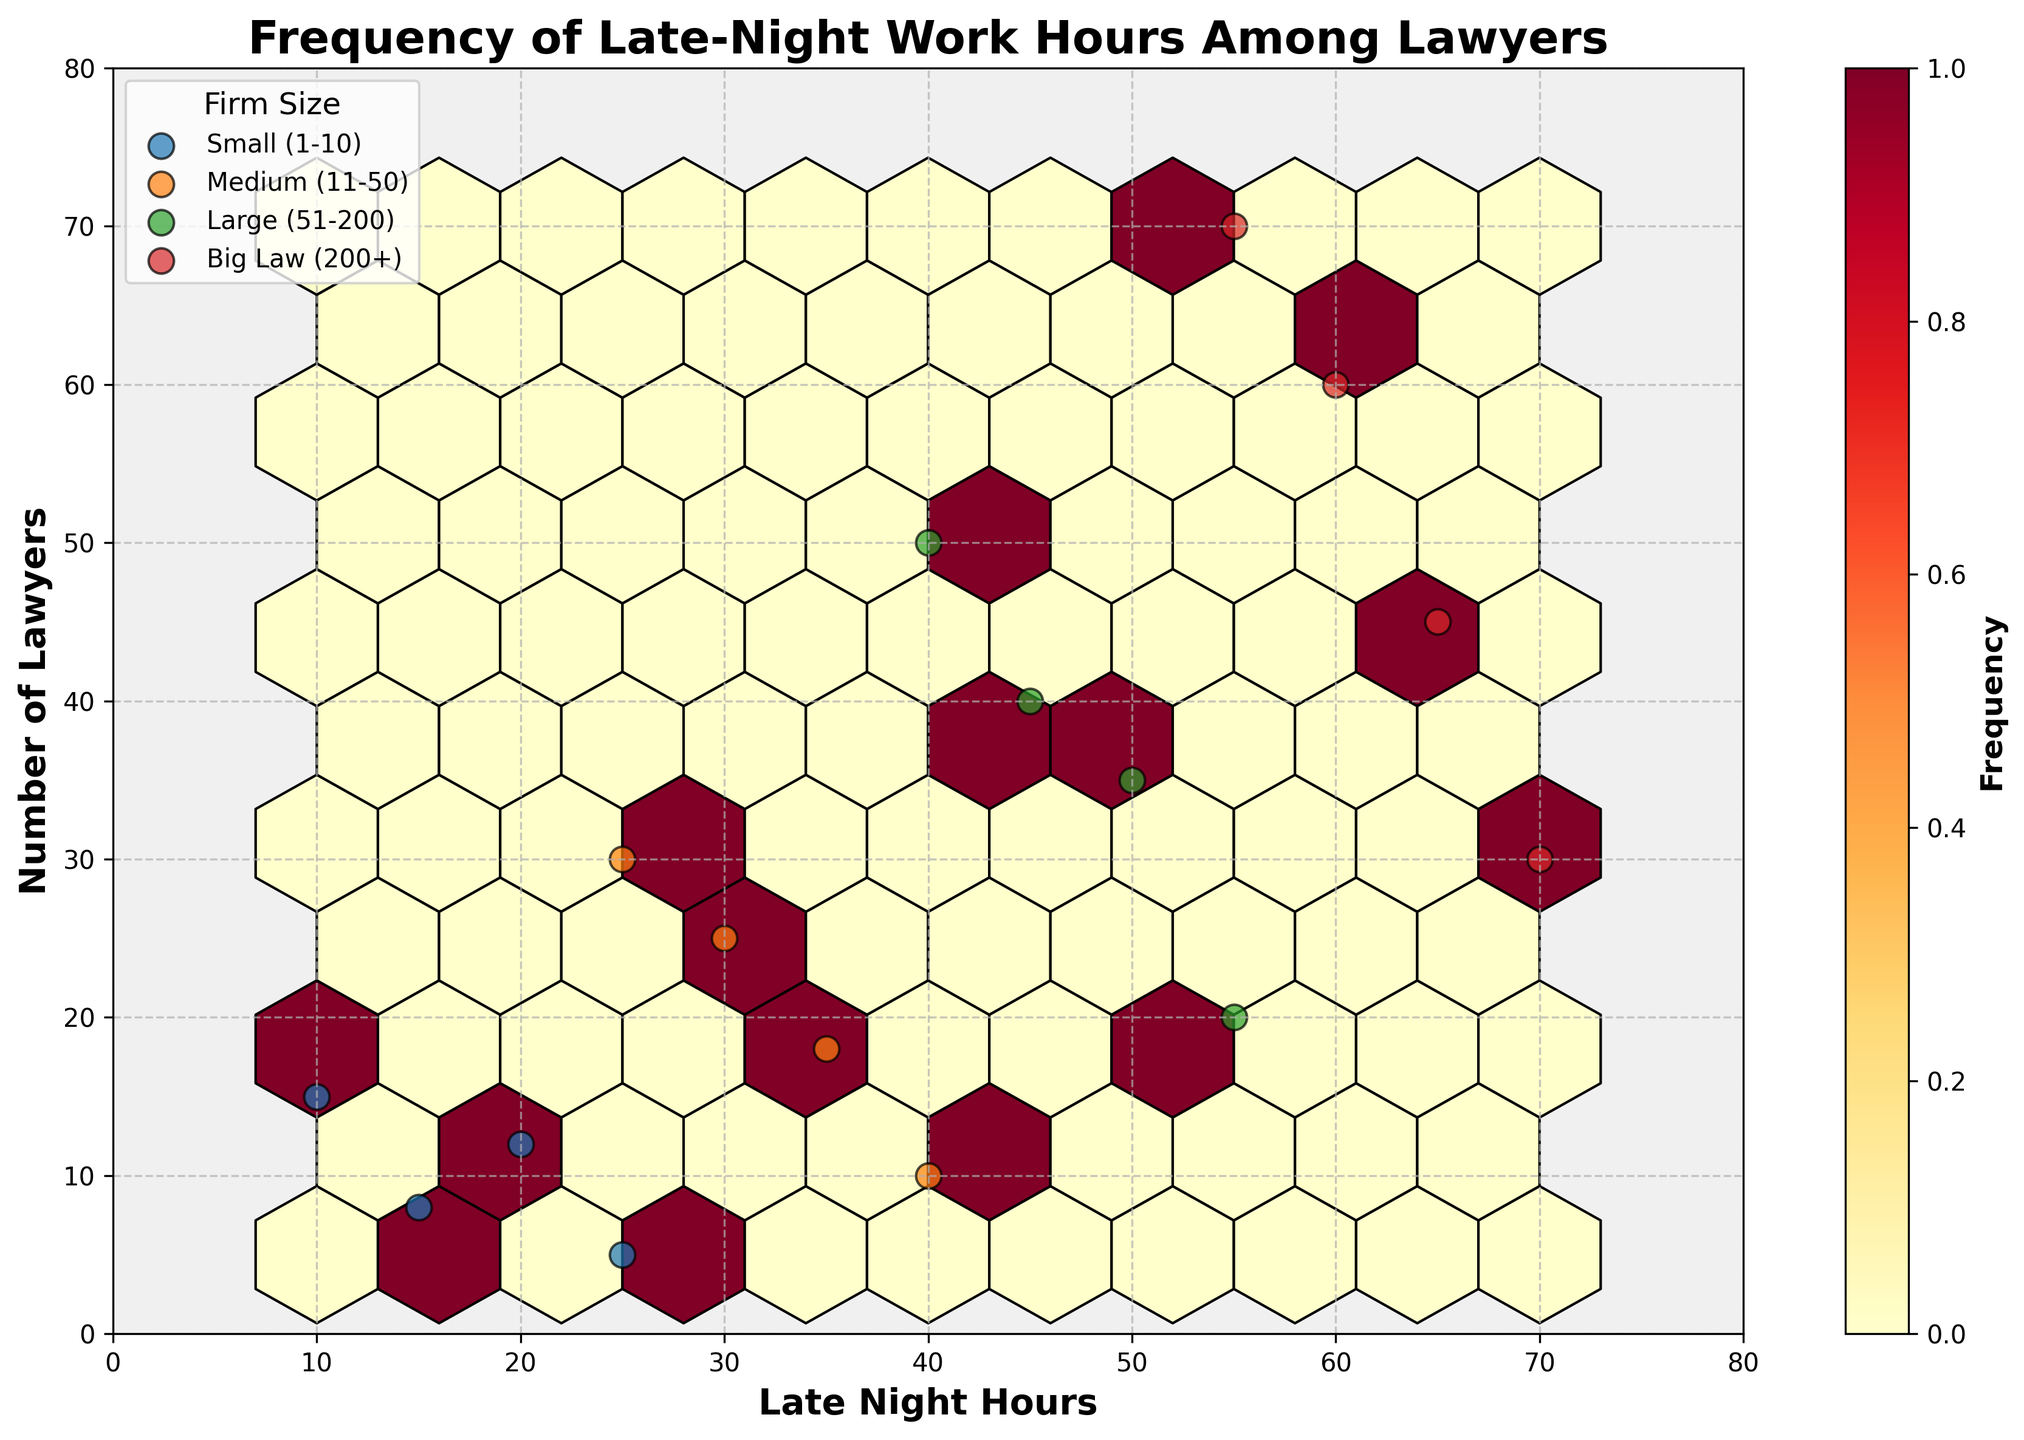What is the title of the plot? The title of the plot is displayed at the top of the figure, and it reads "Frequency of Late-Night Work Hours Among Lawyers".
Answer: Frequency of Late-Night Work Hours Among Lawyers Which axis represents the 'Late Night Hours'? The x-axis represents the 'Late Night Hours,' as labeled on the horizontal line at the bottom of the plot.
Answer: x-axis What color is used for the hexagons in the hexbin plot? The hexagons in the hexbin plot are colored using a gradient from yellow to red, as indicated by the color map 'YlOrRd'.
Answer: Yellow to red gradient Is there a color bar included in the plot? Yes, there is a color bar included on the right side of the plot that indicates the frequency of late-night work hours.
Answer: Yes Which firm size has the highest number of lawyers working late-night hours? By observing the scattered points, 'Big Law (200+)' has instances where 60, 65 and 70 lawyers work late-night hours, which are the highest counts among all firm sizes in the plot.
Answer: Big Law (200+) What is the range of the 'Number of Lawyers' axis? The y-axis range, representing the 'Number of Lawyers,' is from 0 to 80 as visible from the ticks along the vertical axis.
Answer: 0 to 80 How does the number of late-night work hours correlate with the number of lawyers in small firms (1-10)? To analyze this, look at the scatter points for 'Small (1-10)' firms. They show varying late-night hours (10, 15, 20, 25) with a smaller number of lawyers, indicating a positive correlation where increased late-night hours generally accompany more lawyers, though on a smaller scale.
Answer: Positive correlation Among the visible firm sizes, which one shows the widest range of late-night work hours? 'Big Law (200+)' displays the widest range of late-night work hours from 55 to 70 hours, which is more extended compared to the other firm sizes in the plot.
Answer: Big Law (200+) Which group appears to have the densest clustering of hexagons? The densest clustering of hexagons, indicated by the darkest red color in the hexbin, appears where 'Medium (11-50)' firms spend around 25-30 late-night hours with a number of lawyers between 20-30.
Answer: Medium (11-50) 